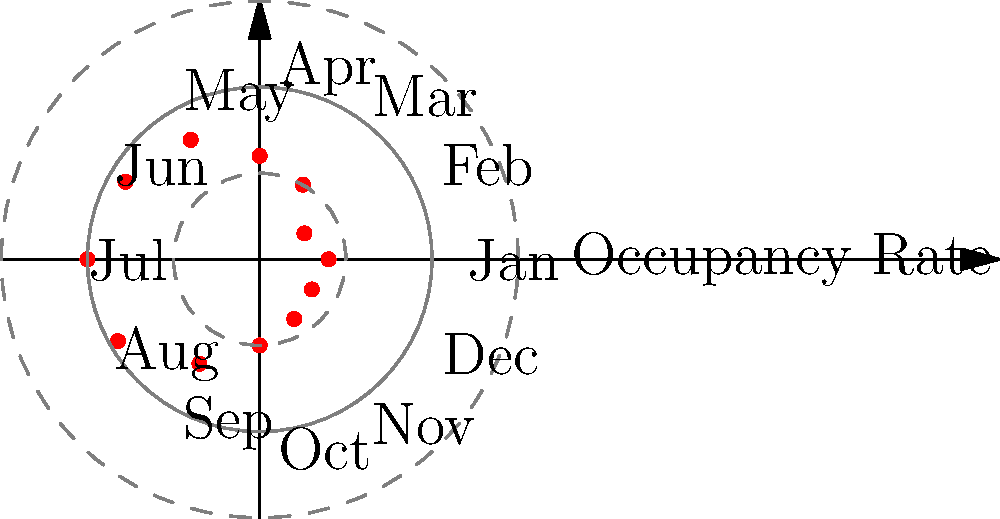Given the polar coordinate plot of seasonal occupancy rates for a family-owned guesthouse, which month shows the highest occupancy rate, and what is the approximate value? To answer this question, we need to follow these steps:

1. Understand the polar coordinate system: In this plot, the distance from the center represents the occupancy rate, while the angle represents the month.

2. Identify the outermost point: The point farthest from the center corresponds to the highest occupancy rate.

3. Locate the month: The outermost point is aligned with the label "Jul" on the circumference.

4. Estimate the value: The outermost point appears to touch the outer dashed circle, which represents a value of 1.0 or 100% occupancy.

5. Confirm the highest rate: No other points on the plot extend as far from the center as the July point.

Therefore, July shows the highest occupancy rate at approximately 100%.
Answer: July, 100% 